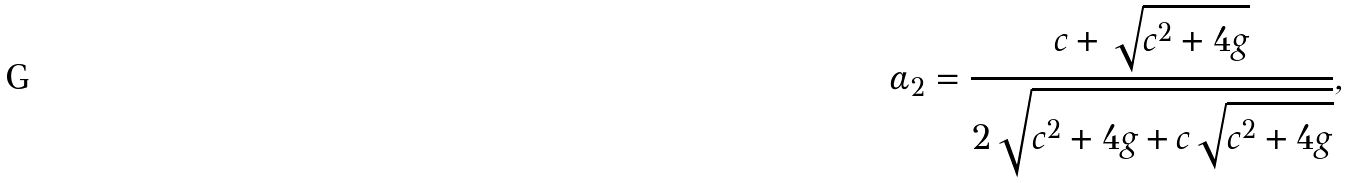Convert formula to latex. <formula><loc_0><loc_0><loc_500><loc_500>\alpha _ { 2 } = \frac { c + \sqrt { c ^ { 2 } + 4 g } } { 2 \sqrt { c ^ { 2 } + 4 g + c \sqrt { c ^ { 2 } + 4 g } } } ,</formula> 